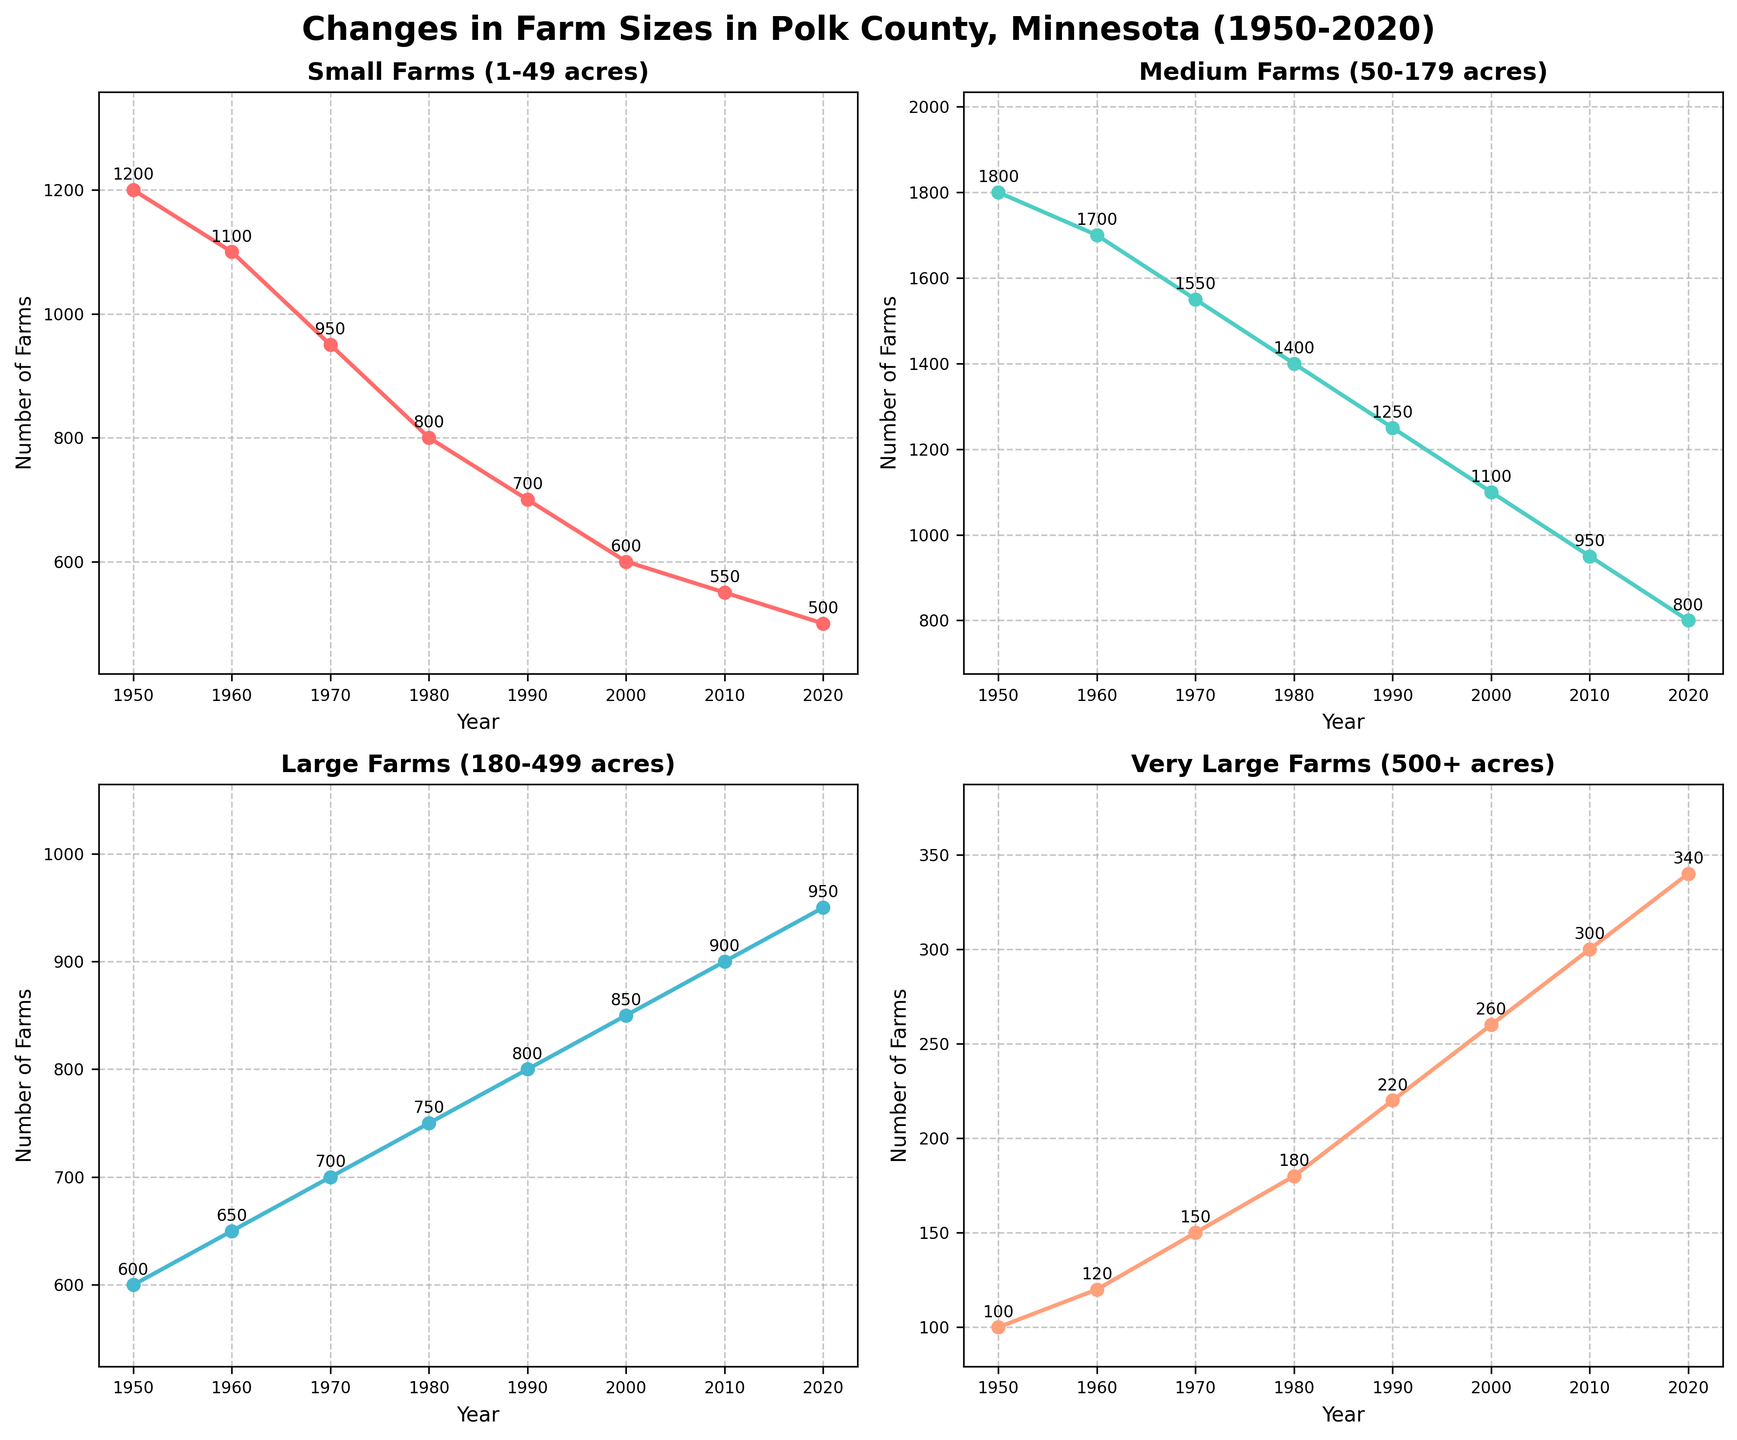Which category of farms showed the greatest increase in the number of farms between 1950 and 2020? To find the category with the greatest increase, we need to look at the difference in the number of farms between 1950 and 2020 for each category. Very Large Farms (500+ acres) increased from 100 to 340, which is the largest increase among the categories.
Answer: Very Large Farms (500+ acres) Which category of farms showed the greatest decrease in the number of farms between 1950 and 2020? We need to look at the difference in the number of farms between 1950 and 2020 for each category. Small Farms (1-49 acres) decreased from 1200 to 500, showing the greatest decrease.
Answer: Small Farms (1-49 acres) In which decade did the number of Medium Farms (50-179 acres) decrease the most? We find the differences in the number of Medium Farms between each decade. From 2010 to 2020, the number dropped from 950 to 800, a decrease of 150 farms, which is the greatest decrease in any decade.
Answer: 2010-2020 Compare the number of Large Farms (180-499 acres) in 1950 and 2020. Which year has a higher number, and by how much? In 1950, there were 600 Large Farms, and in 2020, there were 950. The number of Large Farms in 2020 is higher by 950 - 600 = 350 farms.
Answer: 2020, by 350 farms What is the trend for the number of Very Large Farms (500+ acres) from 1950 to 2020? Reviewing the plot for Very Large Farms (500+ acres), we observe a consistent upward trend. The number increases from 100 in 1950 to 340 in 2020.
Answer: Increasing What is the combined number of Small and Medium Farms in 1980? We need to add the number of Small Farms and Medium Farms in 1980. Small Farms: 800, Medium Farms: 1400. The combined number is 800 + 1400 = 2200 farms.
Answer: 2200 farms Which category had more farms in 2000, Small Farms or Medium Farms? In 2000, the number of Small Farms was 600 and Medium Farms was 1100. Medium Farms had more farms.
Answer: Medium Farms In which year did the number of Small Farms (1-49 acres) fall below the number of Medium Farms (50-179 acres)? Observing the chart, small farms fall below medium farms in the decade from 1950 to 1960, but the specific year when it falls below is not explicitly shown in the figure. We can infer that by 1960, small farms are below medium farms. Therefore, it happened sometime between 1950 and 1960.
Answer: Between 1950 and 1960 During which period did the number of Large Farms (180-499 acres) surpass the number of Medium Farms (50-179 acres)? We examine the chart and notice that in 2010, Large Farms equaled Medium Farms in number (900 farms). By 2020, the number of Large Farms was greater than Medium Farms. So, it happened between 2010 and 2020.
Answer: Between 2010 and 2020 